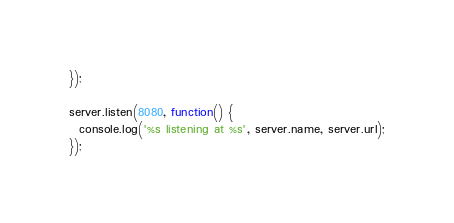<code> <loc_0><loc_0><loc_500><loc_500><_JavaScript_>});

server.listen(8080, function() {
  console.log('%s listening at %s', server.name, server.url);
});
</code> 